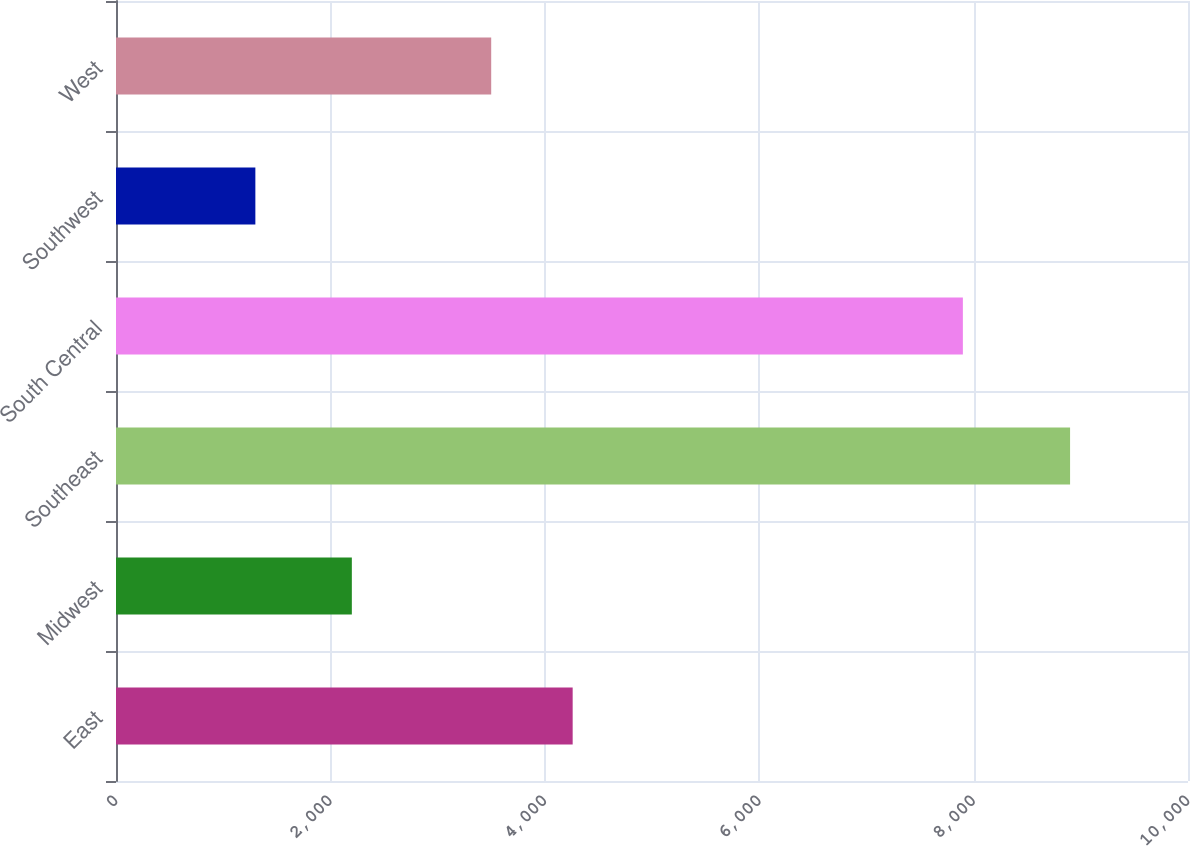Convert chart to OTSL. <chart><loc_0><loc_0><loc_500><loc_500><bar_chart><fcel>East<fcel>Midwest<fcel>Southeast<fcel>South Central<fcel>Southwest<fcel>West<nl><fcel>4260<fcel>2200<fcel>8900<fcel>7900<fcel>1300<fcel>3500<nl></chart> 